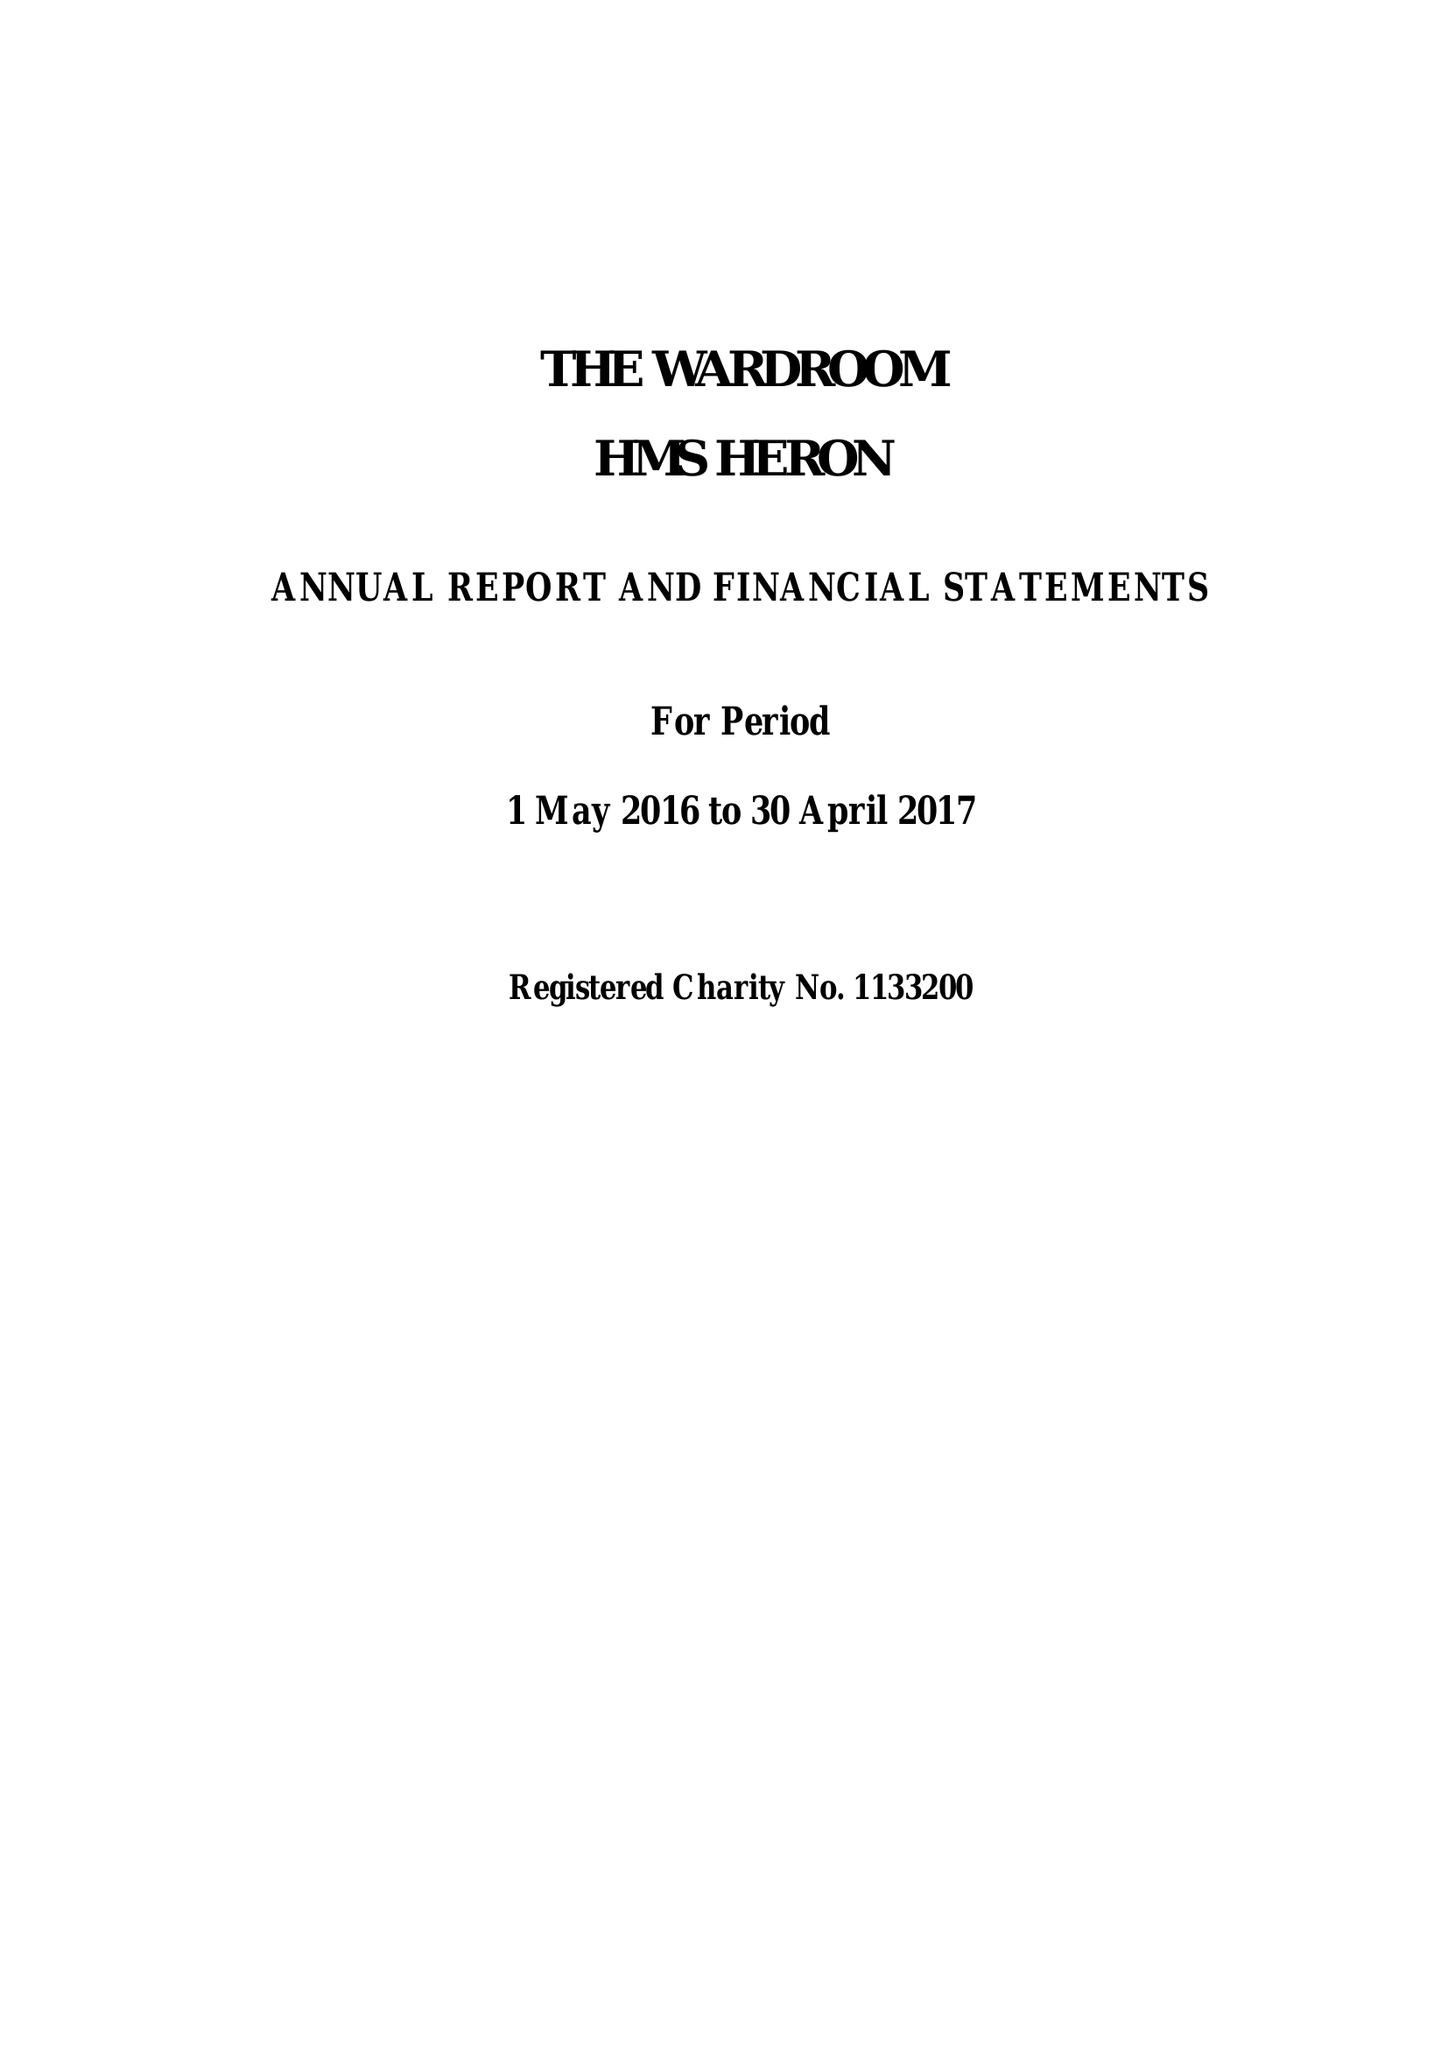What is the value for the address__postcode?
Answer the question using a single word or phrase. BA22 8HT 